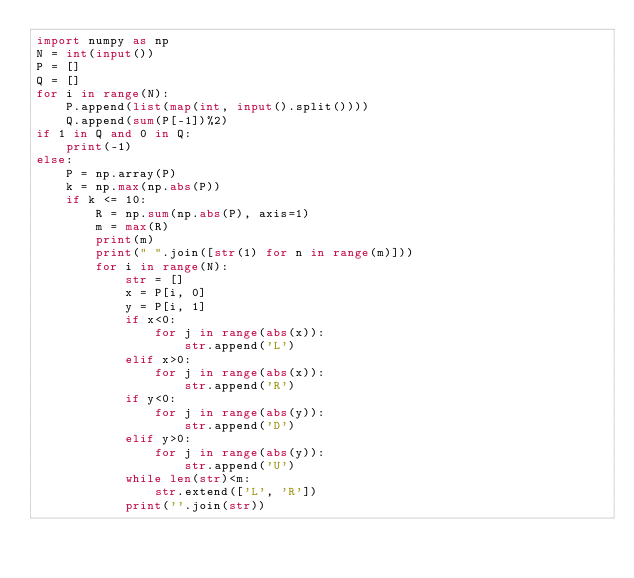<code> <loc_0><loc_0><loc_500><loc_500><_Python_>import numpy as np
N = int(input())
P = []
Q = []
for i in range(N):
    P.append(list(map(int, input().split())))
    Q.append(sum(P[-1])%2)
if 1 in Q and 0 in Q:
    print(-1)
else:
    P = np.array(P)
    k = np.max(np.abs(P))
    if k <= 10:
        R = np.sum(np.abs(P), axis=1)
        m = max(R)
        print(m)
        print(" ".join([str(1) for n in range(m)]))
        for i in range(N):
            str = []
            x = P[i, 0]
            y = P[i, 1]
            if x<0:
                for j in range(abs(x)):
                    str.append('L')
            elif x>0:
                for j in range(abs(x)):
                    str.append('R')
            if y<0:
                for j in range(abs(y)):
                    str.append('D')
            elif y>0:
                for j in range(abs(y)):
                    str.append('U')
            while len(str)<m:
                str.extend(['L', 'R'])
            print(''.join(str))</code> 